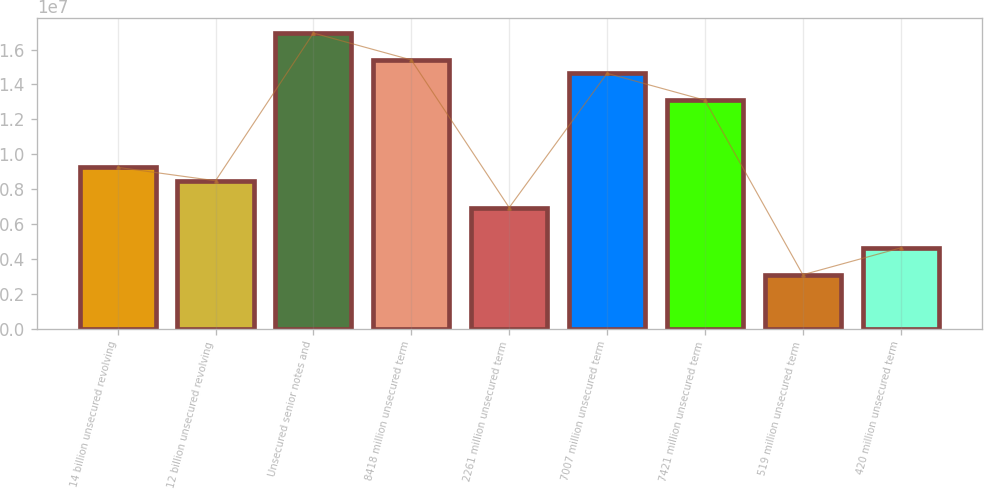Convert chart to OTSL. <chart><loc_0><loc_0><loc_500><loc_500><bar_chart><fcel>14 billion unsecured revolving<fcel>12 billion unsecured revolving<fcel>Unsecured senior notes and<fcel>8418 million unsecured term<fcel>2261 million unsecured term<fcel>7007 million unsecured term<fcel>7421 million unsecured term<fcel>519 million unsecured term<fcel>420 million unsecured term<nl><fcel>9.24684e+06<fcel>8.47672e+06<fcel>1.6948e+07<fcel>1.54078e+07<fcel>6.93648e+06<fcel>1.46377e+07<fcel>1.30974e+07<fcel>3.08588e+06<fcel>4.62612e+06<nl></chart> 